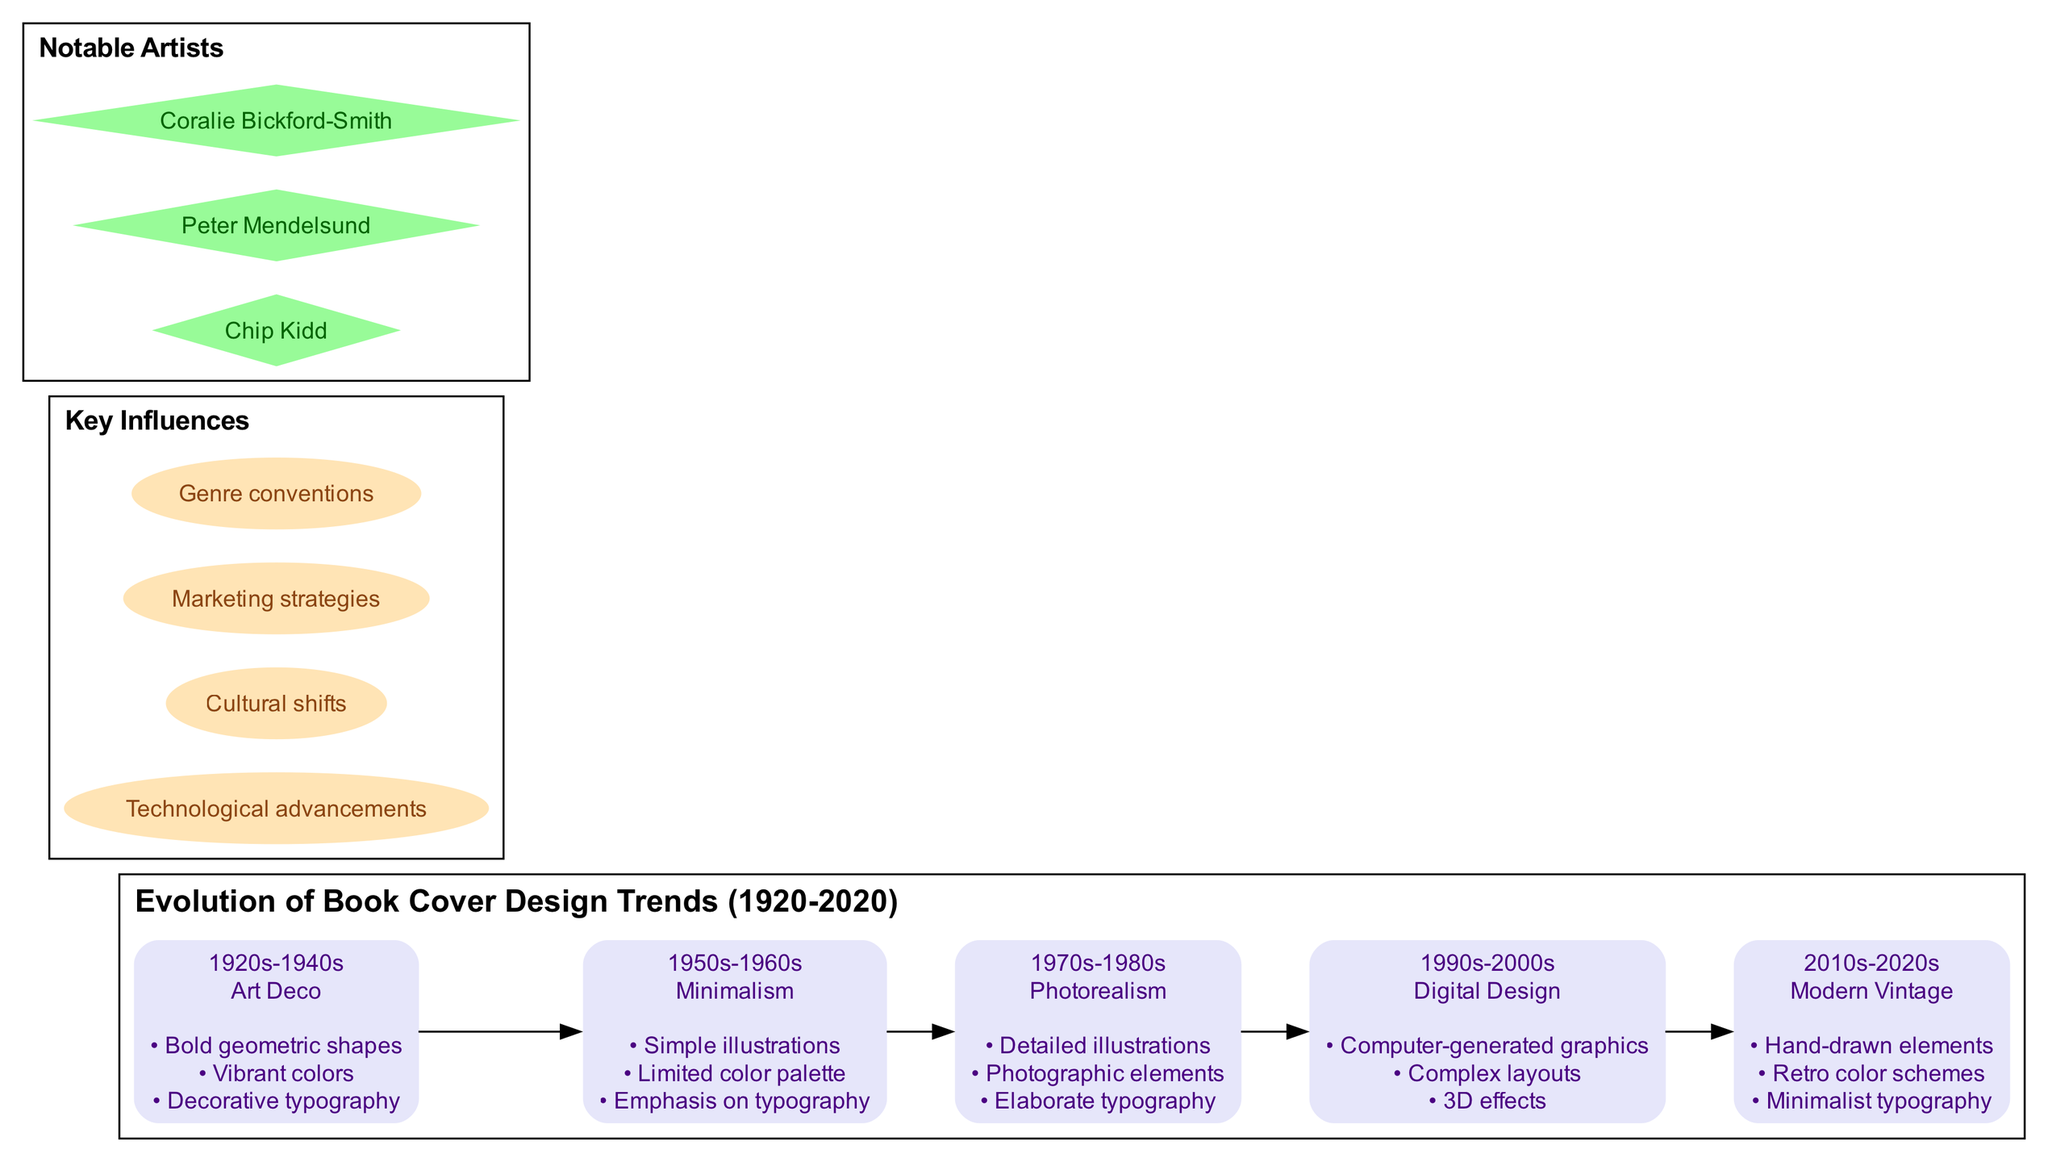What style is associated with the 1950s-1960s era? The diagram shows that the 1950s-1960s era features a style called "Minimalism." You can find this information at the node corresponding to that era in the timeline.
Answer: Minimalism How many key influences are listed in the diagram? The diagram presents a total of four key influences. This is determined by counting the nodes under the "Key Influences" section.
Answer: 4 Which book cover design style features "Hand-drawn elements"? By looking at the timeline in the diagram, the style featuring "Hand-drawn elements" is associated with the 2010s-2020s era under "Modern Vintage". This information can be accessed by examining the respective node.
Answer: Modern Vintage What are the notable artists mentioned in the diagram? The diagram includes three notable artists: Chip Kidd, Peter Mendelsund, and Coralie Bickford-Smith. Each artist is represented as a separate node in the "Notable Artists" section.
Answer: Chip Kidd, Peter Mendelsund, Coralie Bickford-Smith What era is characterized by "Bold geometric shapes" and "Vibrant colors"? These features are specifically mentioned in the timeline for the 1920s-1940s era under the "Art Deco" style. Therefore, the answer identifying this era can be deduced from those listed features.
Answer: 1920s-1940s How did the design styles evolve from the 1950s-1960s to the 1990s-2000s? This requires analyzing the transition from the "Minimalism" style of the 1950s-1960s, which emphasized simple illustrations and typography, to the "Digital Design" style of the 1990s-2000s that incorporates computer-generated graphics and complex layouts. The evolution reflects a significant shift toward more technological integration in design.
Answer: From Minimalism to Digital Design Which artist is known for their work in book cover design? The diagram lists notable artists, and specifically mentions Chip Kidd. This identification can be made by referring to the "Notable Artists" section and highlighting any one of them as known for cover design work.
Answer: Chip Kidd What is the primary influence on book cover design mentioned in the diagram? Among the four key influences listed, one can determine that "Technological advancements" is a primary influence that significantly impacts the evolution of design, as it is the first to be mentioned in the "Key Influences" section.
Answer: Technological advancements 